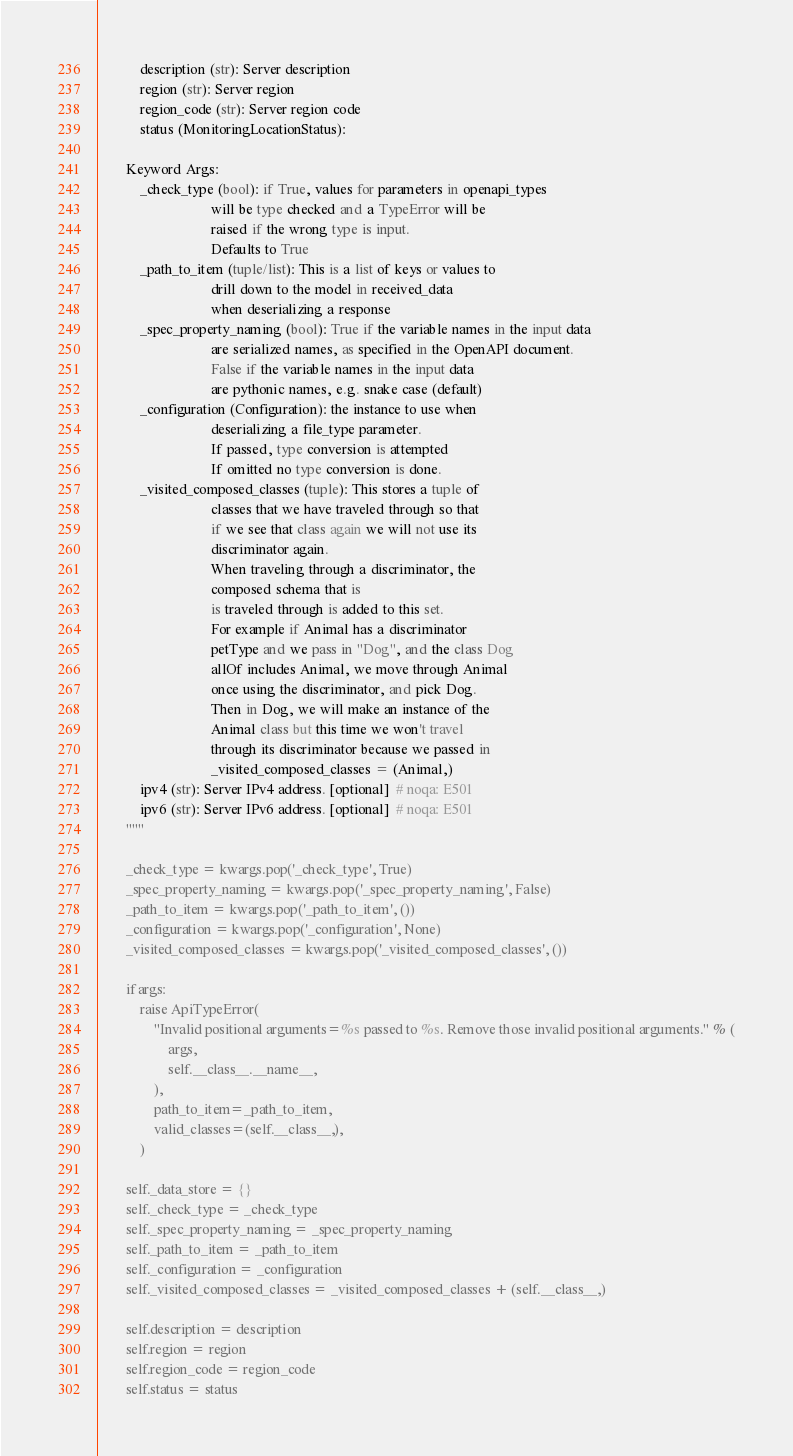<code> <loc_0><loc_0><loc_500><loc_500><_Python_>            description (str): Server description
            region (str): Server region
            region_code (str): Server region code
            status (MonitoringLocationStatus):

        Keyword Args:
            _check_type (bool): if True, values for parameters in openapi_types
                                will be type checked and a TypeError will be
                                raised if the wrong type is input.
                                Defaults to True
            _path_to_item (tuple/list): This is a list of keys or values to
                                drill down to the model in received_data
                                when deserializing a response
            _spec_property_naming (bool): True if the variable names in the input data
                                are serialized names, as specified in the OpenAPI document.
                                False if the variable names in the input data
                                are pythonic names, e.g. snake case (default)
            _configuration (Configuration): the instance to use when
                                deserializing a file_type parameter.
                                If passed, type conversion is attempted
                                If omitted no type conversion is done.
            _visited_composed_classes (tuple): This stores a tuple of
                                classes that we have traveled through so that
                                if we see that class again we will not use its
                                discriminator again.
                                When traveling through a discriminator, the
                                composed schema that is
                                is traveled through is added to this set.
                                For example if Animal has a discriminator
                                petType and we pass in "Dog", and the class Dog
                                allOf includes Animal, we move through Animal
                                once using the discriminator, and pick Dog.
                                Then in Dog, we will make an instance of the
                                Animal class but this time we won't travel
                                through its discriminator because we passed in
                                _visited_composed_classes = (Animal,)
            ipv4 (str): Server IPv4 address. [optional]  # noqa: E501
            ipv6 (str): Server IPv6 address. [optional]  # noqa: E501
        """

        _check_type = kwargs.pop('_check_type', True)
        _spec_property_naming = kwargs.pop('_spec_property_naming', False)
        _path_to_item = kwargs.pop('_path_to_item', ())
        _configuration = kwargs.pop('_configuration', None)
        _visited_composed_classes = kwargs.pop('_visited_composed_classes', ())

        if args:
            raise ApiTypeError(
                "Invalid positional arguments=%s passed to %s. Remove those invalid positional arguments." % (
                    args,
                    self.__class__.__name__,
                ),
                path_to_item=_path_to_item,
                valid_classes=(self.__class__,),
            )

        self._data_store = {}
        self._check_type = _check_type
        self._spec_property_naming = _spec_property_naming
        self._path_to_item = _path_to_item
        self._configuration = _configuration
        self._visited_composed_classes = _visited_composed_classes + (self.__class__,)

        self.description = description
        self.region = region
        self.region_code = region_code
        self.status = status</code> 